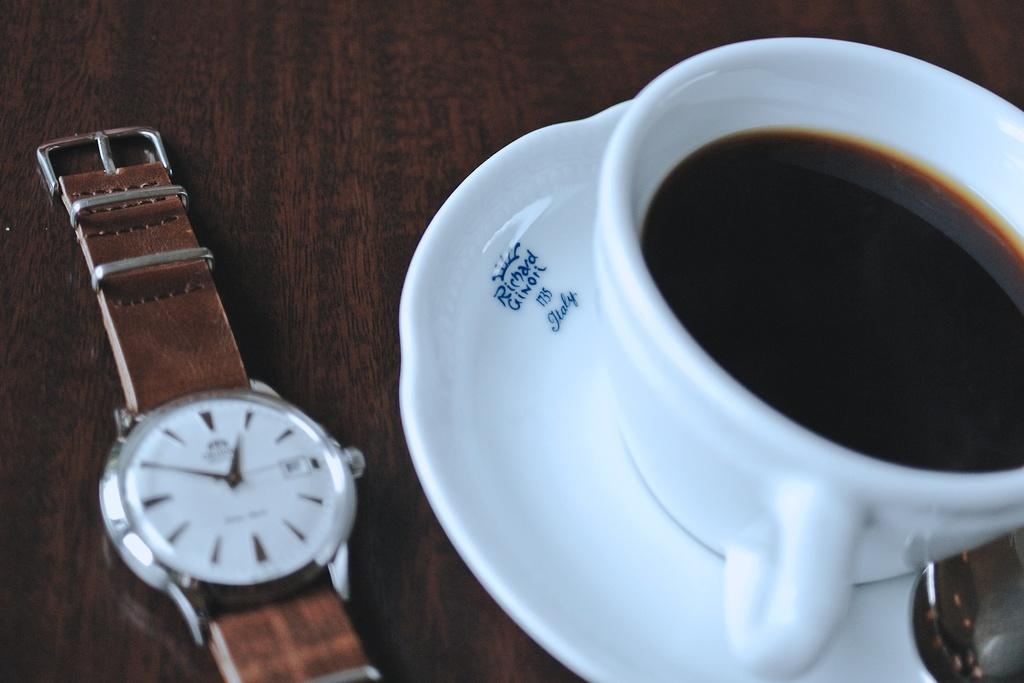<image>
Summarize the visual content of the image. A watch next to a cup and Richard Ginoli coaster. 